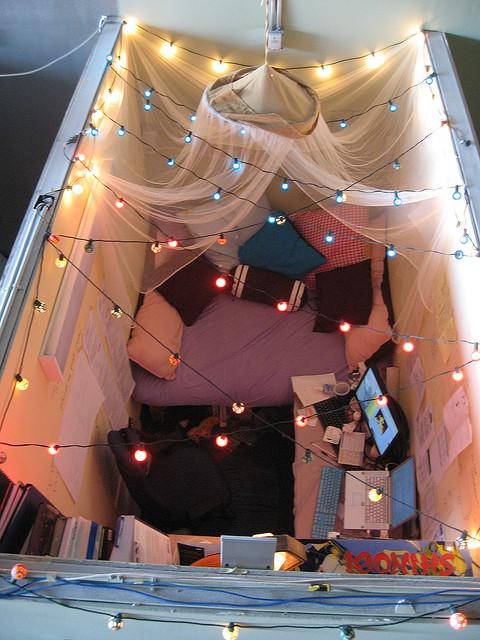Is this a tent?
Concise answer only. No. What is the room used for?
Keep it brief. Office. Does this like a photo from the ground up?
Write a very short answer. No. 